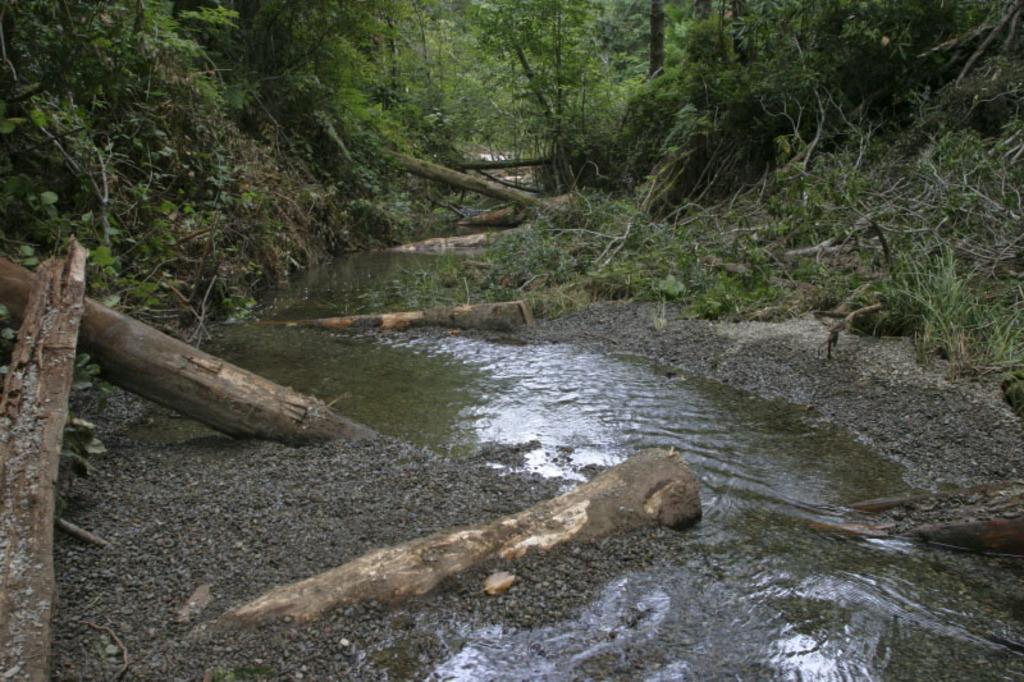What is present in the image that is related to water? There is water visible in the image. What objects can be seen made of tree-trunks in the image? There are tree-trunks in the image. What type of vegetation can be seen in the background of the image? There are trees in the background of the image. What type of paste is being used to hold the trees together in the image? There is no paste present in the image, and the trees are not being held together. What is the size of the dad in the image? There is no dad present in the image. 